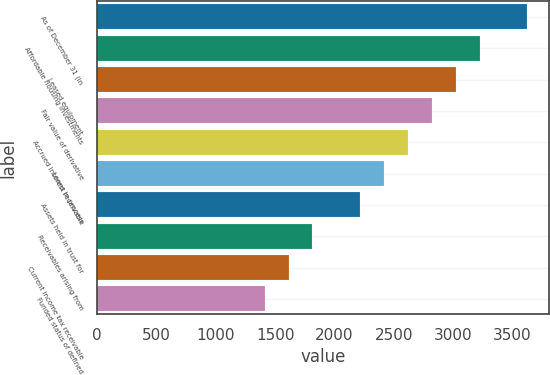Convert chart to OTSL. <chart><loc_0><loc_0><loc_500><loc_500><bar_chart><fcel>As of December 31 (in<fcel>Affordable housing investments<fcel>Leased equipment<fcel>Fair value of derivative<fcel>Accrued interest receivable<fcel>Loans in process<fcel>Assets held in trust for<fcel>Receivables arising from<fcel>Current income tax receivable<fcel>Funded status of defined<nl><fcel>3625.6<fcel>3223.2<fcel>3022<fcel>2820.8<fcel>2619.6<fcel>2418.4<fcel>2217.2<fcel>1814.8<fcel>1613.6<fcel>1412.4<nl></chart> 